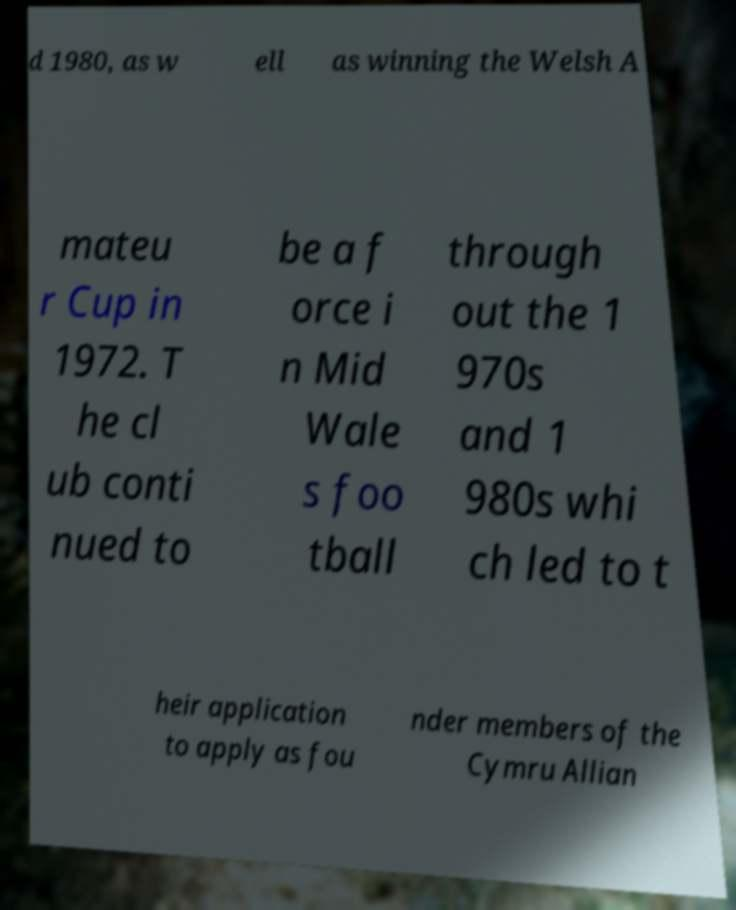What messages or text are displayed in this image? I need them in a readable, typed format. d 1980, as w ell as winning the Welsh A mateu r Cup in 1972. T he cl ub conti nued to be a f orce i n Mid Wale s foo tball through out the 1 970s and 1 980s whi ch led to t heir application to apply as fou nder members of the Cymru Allian 